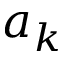Convert formula to latex. <formula><loc_0><loc_0><loc_500><loc_500>a _ { k }</formula> 